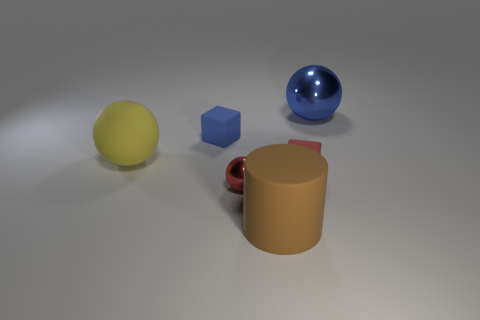Add 1 blue matte objects. How many objects exist? 7 Subtract all blocks. How many objects are left? 4 Add 1 red metal things. How many red metal things are left? 2 Add 5 blue shiny spheres. How many blue shiny spheres exist? 6 Subtract 1 red spheres. How many objects are left? 5 Subtract all large objects. Subtract all big purple blocks. How many objects are left? 3 